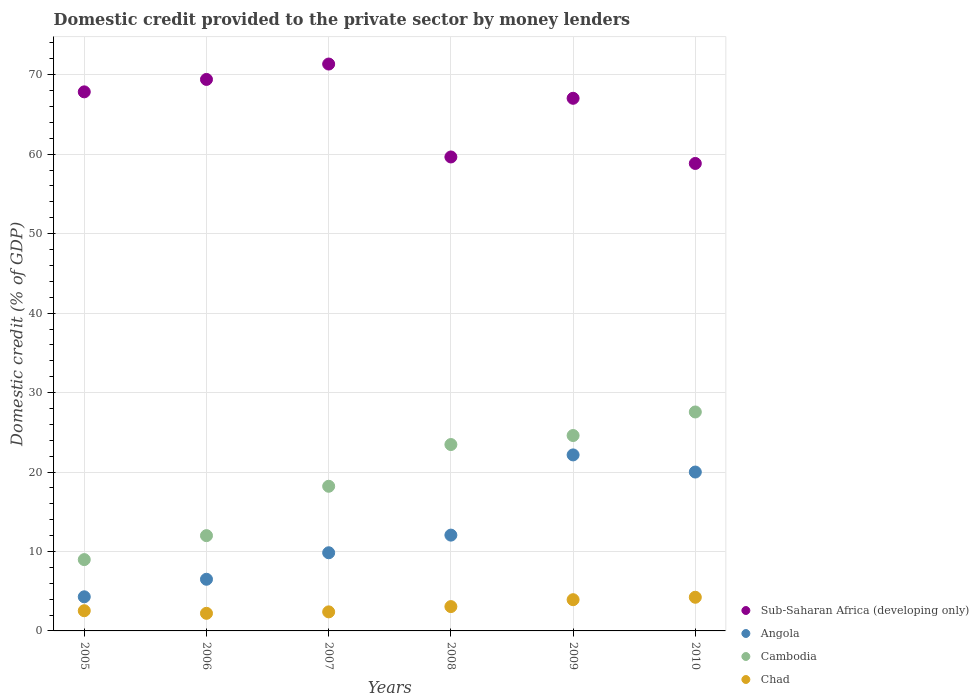How many different coloured dotlines are there?
Offer a very short reply. 4. Is the number of dotlines equal to the number of legend labels?
Offer a very short reply. Yes. What is the domestic credit provided to the private sector by money lenders in Angola in 2007?
Offer a terse response. 9.84. Across all years, what is the maximum domestic credit provided to the private sector by money lenders in Angola?
Offer a very short reply. 22.15. Across all years, what is the minimum domestic credit provided to the private sector by money lenders in Sub-Saharan Africa (developing only)?
Make the answer very short. 58.84. In which year was the domestic credit provided to the private sector by money lenders in Angola minimum?
Offer a very short reply. 2005. What is the total domestic credit provided to the private sector by money lenders in Cambodia in the graph?
Your answer should be compact. 114.79. What is the difference between the domestic credit provided to the private sector by money lenders in Angola in 2005 and that in 2009?
Make the answer very short. -17.86. What is the difference between the domestic credit provided to the private sector by money lenders in Sub-Saharan Africa (developing only) in 2006 and the domestic credit provided to the private sector by money lenders in Cambodia in 2005?
Your answer should be very brief. 60.44. What is the average domestic credit provided to the private sector by money lenders in Chad per year?
Keep it short and to the point. 3.06. In the year 2009, what is the difference between the domestic credit provided to the private sector by money lenders in Sub-Saharan Africa (developing only) and domestic credit provided to the private sector by money lenders in Cambodia?
Provide a short and direct response. 42.45. What is the ratio of the domestic credit provided to the private sector by money lenders in Sub-Saharan Africa (developing only) in 2005 to that in 2006?
Give a very brief answer. 0.98. Is the domestic credit provided to the private sector by money lenders in Sub-Saharan Africa (developing only) in 2008 less than that in 2010?
Give a very brief answer. No. What is the difference between the highest and the second highest domestic credit provided to the private sector by money lenders in Sub-Saharan Africa (developing only)?
Give a very brief answer. 1.94. What is the difference between the highest and the lowest domestic credit provided to the private sector by money lenders in Angola?
Your response must be concise. 17.86. Does the domestic credit provided to the private sector by money lenders in Angola monotonically increase over the years?
Your answer should be very brief. No. How are the legend labels stacked?
Offer a terse response. Vertical. What is the title of the graph?
Offer a very short reply. Domestic credit provided to the private sector by money lenders. Does "Dominica" appear as one of the legend labels in the graph?
Your response must be concise. No. What is the label or title of the Y-axis?
Your answer should be very brief. Domestic credit (% of GDP). What is the Domestic credit (% of GDP) in Sub-Saharan Africa (developing only) in 2005?
Ensure brevity in your answer.  67.85. What is the Domestic credit (% of GDP) in Angola in 2005?
Make the answer very short. 4.29. What is the Domestic credit (% of GDP) in Cambodia in 2005?
Make the answer very short. 8.98. What is the Domestic credit (% of GDP) of Chad in 2005?
Provide a short and direct response. 2.54. What is the Domestic credit (% of GDP) in Sub-Saharan Africa (developing only) in 2006?
Offer a very short reply. 69.41. What is the Domestic credit (% of GDP) of Angola in 2006?
Make the answer very short. 6.5. What is the Domestic credit (% of GDP) in Cambodia in 2006?
Your answer should be very brief. 11.99. What is the Domestic credit (% of GDP) in Chad in 2006?
Provide a succinct answer. 2.22. What is the Domestic credit (% of GDP) in Sub-Saharan Africa (developing only) in 2007?
Make the answer very short. 71.35. What is the Domestic credit (% of GDP) in Angola in 2007?
Offer a terse response. 9.84. What is the Domestic credit (% of GDP) of Cambodia in 2007?
Your answer should be compact. 18.21. What is the Domestic credit (% of GDP) of Chad in 2007?
Your answer should be compact. 2.4. What is the Domestic credit (% of GDP) in Sub-Saharan Africa (developing only) in 2008?
Ensure brevity in your answer.  59.65. What is the Domestic credit (% of GDP) of Angola in 2008?
Make the answer very short. 12.06. What is the Domestic credit (% of GDP) in Cambodia in 2008?
Provide a succinct answer. 23.46. What is the Domestic credit (% of GDP) of Chad in 2008?
Make the answer very short. 3.06. What is the Domestic credit (% of GDP) in Sub-Saharan Africa (developing only) in 2009?
Make the answer very short. 67.04. What is the Domestic credit (% of GDP) of Angola in 2009?
Provide a short and direct response. 22.15. What is the Domestic credit (% of GDP) of Cambodia in 2009?
Make the answer very short. 24.59. What is the Domestic credit (% of GDP) in Chad in 2009?
Make the answer very short. 3.93. What is the Domestic credit (% of GDP) in Sub-Saharan Africa (developing only) in 2010?
Your answer should be compact. 58.84. What is the Domestic credit (% of GDP) in Angola in 2010?
Offer a terse response. 20. What is the Domestic credit (% of GDP) of Cambodia in 2010?
Your answer should be very brief. 27.56. What is the Domestic credit (% of GDP) of Chad in 2010?
Make the answer very short. 4.24. Across all years, what is the maximum Domestic credit (% of GDP) of Sub-Saharan Africa (developing only)?
Give a very brief answer. 71.35. Across all years, what is the maximum Domestic credit (% of GDP) of Angola?
Ensure brevity in your answer.  22.15. Across all years, what is the maximum Domestic credit (% of GDP) of Cambodia?
Ensure brevity in your answer.  27.56. Across all years, what is the maximum Domestic credit (% of GDP) of Chad?
Make the answer very short. 4.24. Across all years, what is the minimum Domestic credit (% of GDP) of Sub-Saharan Africa (developing only)?
Keep it short and to the point. 58.84. Across all years, what is the minimum Domestic credit (% of GDP) in Angola?
Keep it short and to the point. 4.29. Across all years, what is the minimum Domestic credit (% of GDP) in Cambodia?
Your answer should be compact. 8.98. Across all years, what is the minimum Domestic credit (% of GDP) in Chad?
Keep it short and to the point. 2.22. What is the total Domestic credit (% of GDP) in Sub-Saharan Africa (developing only) in the graph?
Keep it short and to the point. 394.14. What is the total Domestic credit (% of GDP) in Angola in the graph?
Make the answer very short. 74.84. What is the total Domestic credit (% of GDP) in Cambodia in the graph?
Your answer should be compact. 114.79. What is the total Domestic credit (% of GDP) in Chad in the graph?
Provide a succinct answer. 18.38. What is the difference between the Domestic credit (% of GDP) in Sub-Saharan Africa (developing only) in 2005 and that in 2006?
Provide a short and direct response. -1.56. What is the difference between the Domestic credit (% of GDP) in Angola in 2005 and that in 2006?
Give a very brief answer. -2.21. What is the difference between the Domestic credit (% of GDP) in Cambodia in 2005 and that in 2006?
Give a very brief answer. -3.02. What is the difference between the Domestic credit (% of GDP) in Chad in 2005 and that in 2006?
Make the answer very short. 0.33. What is the difference between the Domestic credit (% of GDP) in Sub-Saharan Africa (developing only) in 2005 and that in 2007?
Your answer should be compact. -3.5. What is the difference between the Domestic credit (% of GDP) in Angola in 2005 and that in 2007?
Ensure brevity in your answer.  -5.54. What is the difference between the Domestic credit (% of GDP) of Cambodia in 2005 and that in 2007?
Keep it short and to the point. -9.23. What is the difference between the Domestic credit (% of GDP) in Chad in 2005 and that in 2007?
Offer a very short reply. 0.14. What is the difference between the Domestic credit (% of GDP) in Sub-Saharan Africa (developing only) in 2005 and that in 2008?
Make the answer very short. 8.2. What is the difference between the Domestic credit (% of GDP) in Angola in 2005 and that in 2008?
Make the answer very short. -7.76. What is the difference between the Domestic credit (% of GDP) of Cambodia in 2005 and that in 2008?
Provide a short and direct response. -14.48. What is the difference between the Domestic credit (% of GDP) in Chad in 2005 and that in 2008?
Make the answer very short. -0.52. What is the difference between the Domestic credit (% of GDP) in Sub-Saharan Africa (developing only) in 2005 and that in 2009?
Ensure brevity in your answer.  0.81. What is the difference between the Domestic credit (% of GDP) of Angola in 2005 and that in 2009?
Make the answer very short. -17.86. What is the difference between the Domestic credit (% of GDP) of Cambodia in 2005 and that in 2009?
Give a very brief answer. -15.62. What is the difference between the Domestic credit (% of GDP) of Chad in 2005 and that in 2009?
Keep it short and to the point. -1.39. What is the difference between the Domestic credit (% of GDP) in Sub-Saharan Africa (developing only) in 2005 and that in 2010?
Your answer should be compact. 9.01. What is the difference between the Domestic credit (% of GDP) of Angola in 2005 and that in 2010?
Offer a terse response. -15.7. What is the difference between the Domestic credit (% of GDP) in Cambodia in 2005 and that in 2010?
Provide a short and direct response. -18.58. What is the difference between the Domestic credit (% of GDP) in Chad in 2005 and that in 2010?
Keep it short and to the point. -1.7. What is the difference between the Domestic credit (% of GDP) in Sub-Saharan Africa (developing only) in 2006 and that in 2007?
Your response must be concise. -1.94. What is the difference between the Domestic credit (% of GDP) in Angola in 2006 and that in 2007?
Provide a short and direct response. -3.34. What is the difference between the Domestic credit (% of GDP) of Cambodia in 2006 and that in 2007?
Your answer should be compact. -6.21. What is the difference between the Domestic credit (% of GDP) of Chad in 2006 and that in 2007?
Make the answer very short. -0.18. What is the difference between the Domestic credit (% of GDP) in Sub-Saharan Africa (developing only) in 2006 and that in 2008?
Ensure brevity in your answer.  9.76. What is the difference between the Domestic credit (% of GDP) of Angola in 2006 and that in 2008?
Your answer should be very brief. -5.56. What is the difference between the Domestic credit (% of GDP) in Cambodia in 2006 and that in 2008?
Ensure brevity in your answer.  -11.47. What is the difference between the Domestic credit (% of GDP) in Chad in 2006 and that in 2008?
Give a very brief answer. -0.85. What is the difference between the Domestic credit (% of GDP) of Sub-Saharan Africa (developing only) in 2006 and that in 2009?
Provide a succinct answer. 2.37. What is the difference between the Domestic credit (% of GDP) in Angola in 2006 and that in 2009?
Your response must be concise. -15.65. What is the difference between the Domestic credit (% of GDP) in Cambodia in 2006 and that in 2009?
Offer a terse response. -12.6. What is the difference between the Domestic credit (% of GDP) in Chad in 2006 and that in 2009?
Your response must be concise. -1.72. What is the difference between the Domestic credit (% of GDP) of Sub-Saharan Africa (developing only) in 2006 and that in 2010?
Offer a very short reply. 10.58. What is the difference between the Domestic credit (% of GDP) of Angola in 2006 and that in 2010?
Make the answer very short. -13.5. What is the difference between the Domestic credit (% of GDP) in Cambodia in 2006 and that in 2010?
Provide a short and direct response. -15.57. What is the difference between the Domestic credit (% of GDP) in Chad in 2006 and that in 2010?
Make the answer very short. -2.02. What is the difference between the Domestic credit (% of GDP) of Sub-Saharan Africa (developing only) in 2007 and that in 2008?
Offer a very short reply. 11.7. What is the difference between the Domestic credit (% of GDP) of Angola in 2007 and that in 2008?
Ensure brevity in your answer.  -2.22. What is the difference between the Domestic credit (% of GDP) in Cambodia in 2007 and that in 2008?
Offer a terse response. -5.25. What is the difference between the Domestic credit (% of GDP) in Chad in 2007 and that in 2008?
Provide a succinct answer. -0.66. What is the difference between the Domestic credit (% of GDP) in Sub-Saharan Africa (developing only) in 2007 and that in 2009?
Offer a terse response. 4.31. What is the difference between the Domestic credit (% of GDP) of Angola in 2007 and that in 2009?
Your response must be concise. -12.32. What is the difference between the Domestic credit (% of GDP) in Cambodia in 2007 and that in 2009?
Your answer should be very brief. -6.39. What is the difference between the Domestic credit (% of GDP) in Chad in 2007 and that in 2009?
Provide a short and direct response. -1.53. What is the difference between the Domestic credit (% of GDP) of Sub-Saharan Africa (developing only) in 2007 and that in 2010?
Ensure brevity in your answer.  12.51. What is the difference between the Domestic credit (% of GDP) of Angola in 2007 and that in 2010?
Provide a succinct answer. -10.16. What is the difference between the Domestic credit (% of GDP) of Cambodia in 2007 and that in 2010?
Offer a terse response. -9.35. What is the difference between the Domestic credit (% of GDP) of Chad in 2007 and that in 2010?
Your response must be concise. -1.84. What is the difference between the Domestic credit (% of GDP) of Sub-Saharan Africa (developing only) in 2008 and that in 2009?
Make the answer very short. -7.39. What is the difference between the Domestic credit (% of GDP) of Angola in 2008 and that in 2009?
Ensure brevity in your answer.  -10.1. What is the difference between the Domestic credit (% of GDP) in Cambodia in 2008 and that in 2009?
Your answer should be very brief. -1.13. What is the difference between the Domestic credit (% of GDP) of Chad in 2008 and that in 2009?
Ensure brevity in your answer.  -0.87. What is the difference between the Domestic credit (% of GDP) of Sub-Saharan Africa (developing only) in 2008 and that in 2010?
Provide a short and direct response. 0.82. What is the difference between the Domestic credit (% of GDP) in Angola in 2008 and that in 2010?
Your answer should be compact. -7.94. What is the difference between the Domestic credit (% of GDP) in Cambodia in 2008 and that in 2010?
Offer a terse response. -4.1. What is the difference between the Domestic credit (% of GDP) in Chad in 2008 and that in 2010?
Offer a very short reply. -1.17. What is the difference between the Domestic credit (% of GDP) in Sub-Saharan Africa (developing only) in 2009 and that in 2010?
Your answer should be compact. 8.2. What is the difference between the Domestic credit (% of GDP) of Angola in 2009 and that in 2010?
Provide a succinct answer. 2.16. What is the difference between the Domestic credit (% of GDP) of Cambodia in 2009 and that in 2010?
Keep it short and to the point. -2.96. What is the difference between the Domestic credit (% of GDP) of Chad in 2009 and that in 2010?
Your answer should be very brief. -0.31. What is the difference between the Domestic credit (% of GDP) in Sub-Saharan Africa (developing only) in 2005 and the Domestic credit (% of GDP) in Angola in 2006?
Your answer should be compact. 61.35. What is the difference between the Domestic credit (% of GDP) of Sub-Saharan Africa (developing only) in 2005 and the Domestic credit (% of GDP) of Cambodia in 2006?
Keep it short and to the point. 55.86. What is the difference between the Domestic credit (% of GDP) of Sub-Saharan Africa (developing only) in 2005 and the Domestic credit (% of GDP) of Chad in 2006?
Keep it short and to the point. 65.63. What is the difference between the Domestic credit (% of GDP) in Angola in 2005 and the Domestic credit (% of GDP) in Cambodia in 2006?
Your answer should be very brief. -7.7. What is the difference between the Domestic credit (% of GDP) of Angola in 2005 and the Domestic credit (% of GDP) of Chad in 2006?
Your response must be concise. 2.08. What is the difference between the Domestic credit (% of GDP) of Cambodia in 2005 and the Domestic credit (% of GDP) of Chad in 2006?
Your answer should be very brief. 6.76. What is the difference between the Domestic credit (% of GDP) in Sub-Saharan Africa (developing only) in 2005 and the Domestic credit (% of GDP) in Angola in 2007?
Your response must be concise. 58.01. What is the difference between the Domestic credit (% of GDP) in Sub-Saharan Africa (developing only) in 2005 and the Domestic credit (% of GDP) in Cambodia in 2007?
Give a very brief answer. 49.64. What is the difference between the Domestic credit (% of GDP) in Sub-Saharan Africa (developing only) in 2005 and the Domestic credit (% of GDP) in Chad in 2007?
Your answer should be compact. 65.45. What is the difference between the Domestic credit (% of GDP) in Angola in 2005 and the Domestic credit (% of GDP) in Cambodia in 2007?
Your answer should be very brief. -13.91. What is the difference between the Domestic credit (% of GDP) in Angola in 2005 and the Domestic credit (% of GDP) in Chad in 2007?
Keep it short and to the point. 1.9. What is the difference between the Domestic credit (% of GDP) of Cambodia in 2005 and the Domestic credit (% of GDP) of Chad in 2007?
Provide a succinct answer. 6.58. What is the difference between the Domestic credit (% of GDP) in Sub-Saharan Africa (developing only) in 2005 and the Domestic credit (% of GDP) in Angola in 2008?
Your answer should be compact. 55.79. What is the difference between the Domestic credit (% of GDP) in Sub-Saharan Africa (developing only) in 2005 and the Domestic credit (% of GDP) in Cambodia in 2008?
Ensure brevity in your answer.  44.39. What is the difference between the Domestic credit (% of GDP) in Sub-Saharan Africa (developing only) in 2005 and the Domestic credit (% of GDP) in Chad in 2008?
Give a very brief answer. 64.79. What is the difference between the Domestic credit (% of GDP) in Angola in 2005 and the Domestic credit (% of GDP) in Cambodia in 2008?
Your answer should be compact. -19.16. What is the difference between the Domestic credit (% of GDP) in Angola in 2005 and the Domestic credit (% of GDP) in Chad in 2008?
Provide a succinct answer. 1.23. What is the difference between the Domestic credit (% of GDP) of Cambodia in 2005 and the Domestic credit (% of GDP) of Chad in 2008?
Keep it short and to the point. 5.91. What is the difference between the Domestic credit (% of GDP) of Sub-Saharan Africa (developing only) in 2005 and the Domestic credit (% of GDP) of Angola in 2009?
Your answer should be very brief. 45.7. What is the difference between the Domestic credit (% of GDP) in Sub-Saharan Africa (developing only) in 2005 and the Domestic credit (% of GDP) in Cambodia in 2009?
Your answer should be compact. 43.26. What is the difference between the Domestic credit (% of GDP) of Sub-Saharan Africa (developing only) in 2005 and the Domestic credit (% of GDP) of Chad in 2009?
Your answer should be very brief. 63.92. What is the difference between the Domestic credit (% of GDP) in Angola in 2005 and the Domestic credit (% of GDP) in Cambodia in 2009?
Give a very brief answer. -20.3. What is the difference between the Domestic credit (% of GDP) in Angola in 2005 and the Domestic credit (% of GDP) in Chad in 2009?
Keep it short and to the point. 0.36. What is the difference between the Domestic credit (% of GDP) in Cambodia in 2005 and the Domestic credit (% of GDP) in Chad in 2009?
Provide a succinct answer. 5.05. What is the difference between the Domestic credit (% of GDP) in Sub-Saharan Africa (developing only) in 2005 and the Domestic credit (% of GDP) in Angola in 2010?
Offer a very short reply. 47.85. What is the difference between the Domestic credit (% of GDP) of Sub-Saharan Africa (developing only) in 2005 and the Domestic credit (% of GDP) of Cambodia in 2010?
Your answer should be very brief. 40.29. What is the difference between the Domestic credit (% of GDP) in Sub-Saharan Africa (developing only) in 2005 and the Domestic credit (% of GDP) in Chad in 2010?
Your response must be concise. 63.61. What is the difference between the Domestic credit (% of GDP) of Angola in 2005 and the Domestic credit (% of GDP) of Cambodia in 2010?
Provide a short and direct response. -23.26. What is the difference between the Domestic credit (% of GDP) of Angola in 2005 and the Domestic credit (% of GDP) of Chad in 2010?
Offer a very short reply. 0.06. What is the difference between the Domestic credit (% of GDP) in Cambodia in 2005 and the Domestic credit (% of GDP) in Chad in 2010?
Make the answer very short. 4.74. What is the difference between the Domestic credit (% of GDP) in Sub-Saharan Africa (developing only) in 2006 and the Domestic credit (% of GDP) in Angola in 2007?
Your answer should be very brief. 59.58. What is the difference between the Domestic credit (% of GDP) of Sub-Saharan Africa (developing only) in 2006 and the Domestic credit (% of GDP) of Cambodia in 2007?
Keep it short and to the point. 51.21. What is the difference between the Domestic credit (% of GDP) of Sub-Saharan Africa (developing only) in 2006 and the Domestic credit (% of GDP) of Chad in 2007?
Provide a succinct answer. 67.02. What is the difference between the Domestic credit (% of GDP) in Angola in 2006 and the Domestic credit (% of GDP) in Cambodia in 2007?
Your answer should be compact. -11.7. What is the difference between the Domestic credit (% of GDP) of Angola in 2006 and the Domestic credit (% of GDP) of Chad in 2007?
Give a very brief answer. 4.1. What is the difference between the Domestic credit (% of GDP) in Cambodia in 2006 and the Domestic credit (% of GDP) in Chad in 2007?
Your response must be concise. 9.59. What is the difference between the Domestic credit (% of GDP) in Sub-Saharan Africa (developing only) in 2006 and the Domestic credit (% of GDP) in Angola in 2008?
Give a very brief answer. 57.36. What is the difference between the Domestic credit (% of GDP) in Sub-Saharan Africa (developing only) in 2006 and the Domestic credit (% of GDP) in Cambodia in 2008?
Your answer should be very brief. 45.95. What is the difference between the Domestic credit (% of GDP) in Sub-Saharan Africa (developing only) in 2006 and the Domestic credit (% of GDP) in Chad in 2008?
Your response must be concise. 66.35. What is the difference between the Domestic credit (% of GDP) of Angola in 2006 and the Domestic credit (% of GDP) of Cambodia in 2008?
Keep it short and to the point. -16.96. What is the difference between the Domestic credit (% of GDP) of Angola in 2006 and the Domestic credit (% of GDP) of Chad in 2008?
Your answer should be compact. 3.44. What is the difference between the Domestic credit (% of GDP) in Cambodia in 2006 and the Domestic credit (% of GDP) in Chad in 2008?
Offer a very short reply. 8.93. What is the difference between the Domestic credit (% of GDP) of Sub-Saharan Africa (developing only) in 2006 and the Domestic credit (% of GDP) of Angola in 2009?
Make the answer very short. 47.26. What is the difference between the Domestic credit (% of GDP) in Sub-Saharan Africa (developing only) in 2006 and the Domestic credit (% of GDP) in Cambodia in 2009?
Make the answer very short. 44.82. What is the difference between the Domestic credit (% of GDP) in Sub-Saharan Africa (developing only) in 2006 and the Domestic credit (% of GDP) in Chad in 2009?
Offer a very short reply. 65.48. What is the difference between the Domestic credit (% of GDP) of Angola in 2006 and the Domestic credit (% of GDP) of Cambodia in 2009?
Offer a very short reply. -18.09. What is the difference between the Domestic credit (% of GDP) in Angola in 2006 and the Domestic credit (% of GDP) in Chad in 2009?
Give a very brief answer. 2.57. What is the difference between the Domestic credit (% of GDP) in Cambodia in 2006 and the Domestic credit (% of GDP) in Chad in 2009?
Your answer should be very brief. 8.06. What is the difference between the Domestic credit (% of GDP) in Sub-Saharan Africa (developing only) in 2006 and the Domestic credit (% of GDP) in Angola in 2010?
Provide a succinct answer. 49.42. What is the difference between the Domestic credit (% of GDP) in Sub-Saharan Africa (developing only) in 2006 and the Domestic credit (% of GDP) in Cambodia in 2010?
Your answer should be compact. 41.86. What is the difference between the Domestic credit (% of GDP) of Sub-Saharan Africa (developing only) in 2006 and the Domestic credit (% of GDP) of Chad in 2010?
Your answer should be very brief. 65.18. What is the difference between the Domestic credit (% of GDP) in Angola in 2006 and the Domestic credit (% of GDP) in Cambodia in 2010?
Offer a very short reply. -21.06. What is the difference between the Domestic credit (% of GDP) of Angola in 2006 and the Domestic credit (% of GDP) of Chad in 2010?
Ensure brevity in your answer.  2.27. What is the difference between the Domestic credit (% of GDP) in Cambodia in 2006 and the Domestic credit (% of GDP) in Chad in 2010?
Your answer should be very brief. 7.76. What is the difference between the Domestic credit (% of GDP) of Sub-Saharan Africa (developing only) in 2007 and the Domestic credit (% of GDP) of Angola in 2008?
Provide a succinct answer. 59.29. What is the difference between the Domestic credit (% of GDP) of Sub-Saharan Africa (developing only) in 2007 and the Domestic credit (% of GDP) of Cambodia in 2008?
Your response must be concise. 47.89. What is the difference between the Domestic credit (% of GDP) in Sub-Saharan Africa (developing only) in 2007 and the Domestic credit (% of GDP) in Chad in 2008?
Ensure brevity in your answer.  68.29. What is the difference between the Domestic credit (% of GDP) of Angola in 2007 and the Domestic credit (% of GDP) of Cambodia in 2008?
Your answer should be compact. -13.62. What is the difference between the Domestic credit (% of GDP) in Angola in 2007 and the Domestic credit (% of GDP) in Chad in 2008?
Offer a terse response. 6.78. What is the difference between the Domestic credit (% of GDP) of Cambodia in 2007 and the Domestic credit (% of GDP) of Chad in 2008?
Provide a short and direct response. 15.14. What is the difference between the Domestic credit (% of GDP) of Sub-Saharan Africa (developing only) in 2007 and the Domestic credit (% of GDP) of Angola in 2009?
Provide a short and direct response. 49.2. What is the difference between the Domestic credit (% of GDP) of Sub-Saharan Africa (developing only) in 2007 and the Domestic credit (% of GDP) of Cambodia in 2009?
Ensure brevity in your answer.  46.76. What is the difference between the Domestic credit (% of GDP) in Sub-Saharan Africa (developing only) in 2007 and the Domestic credit (% of GDP) in Chad in 2009?
Make the answer very short. 67.42. What is the difference between the Domestic credit (% of GDP) in Angola in 2007 and the Domestic credit (% of GDP) in Cambodia in 2009?
Make the answer very short. -14.76. What is the difference between the Domestic credit (% of GDP) in Angola in 2007 and the Domestic credit (% of GDP) in Chad in 2009?
Keep it short and to the point. 5.91. What is the difference between the Domestic credit (% of GDP) in Cambodia in 2007 and the Domestic credit (% of GDP) in Chad in 2009?
Offer a very short reply. 14.28. What is the difference between the Domestic credit (% of GDP) of Sub-Saharan Africa (developing only) in 2007 and the Domestic credit (% of GDP) of Angola in 2010?
Provide a short and direct response. 51.35. What is the difference between the Domestic credit (% of GDP) in Sub-Saharan Africa (developing only) in 2007 and the Domestic credit (% of GDP) in Cambodia in 2010?
Provide a succinct answer. 43.79. What is the difference between the Domestic credit (% of GDP) of Sub-Saharan Africa (developing only) in 2007 and the Domestic credit (% of GDP) of Chad in 2010?
Your response must be concise. 67.11. What is the difference between the Domestic credit (% of GDP) of Angola in 2007 and the Domestic credit (% of GDP) of Cambodia in 2010?
Provide a succinct answer. -17.72. What is the difference between the Domestic credit (% of GDP) of Angola in 2007 and the Domestic credit (% of GDP) of Chad in 2010?
Your response must be concise. 5.6. What is the difference between the Domestic credit (% of GDP) in Cambodia in 2007 and the Domestic credit (% of GDP) in Chad in 2010?
Offer a very short reply. 13.97. What is the difference between the Domestic credit (% of GDP) of Sub-Saharan Africa (developing only) in 2008 and the Domestic credit (% of GDP) of Angola in 2009?
Provide a short and direct response. 37.5. What is the difference between the Domestic credit (% of GDP) of Sub-Saharan Africa (developing only) in 2008 and the Domestic credit (% of GDP) of Cambodia in 2009?
Your response must be concise. 35.06. What is the difference between the Domestic credit (% of GDP) in Sub-Saharan Africa (developing only) in 2008 and the Domestic credit (% of GDP) in Chad in 2009?
Provide a short and direct response. 55.72. What is the difference between the Domestic credit (% of GDP) in Angola in 2008 and the Domestic credit (% of GDP) in Cambodia in 2009?
Keep it short and to the point. -12.54. What is the difference between the Domestic credit (% of GDP) of Angola in 2008 and the Domestic credit (% of GDP) of Chad in 2009?
Keep it short and to the point. 8.13. What is the difference between the Domestic credit (% of GDP) of Cambodia in 2008 and the Domestic credit (% of GDP) of Chad in 2009?
Your answer should be very brief. 19.53. What is the difference between the Domestic credit (% of GDP) in Sub-Saharan Africa (developing only) in 2008 and the Domestic credit (% of GDP) in Angola in 2010?
Provide a short and direct response. 39.66. What is the difference between the Domestic credit (% of GDP) in Sub-Saharan Africa (developing only) in 2008 and the Domestic credit (% of GDP) in Cambodia in 2010?
Offer a terse response. 32.1. What is the difference between the Domestic credit (% of GDP) in Sub-Saharan Africa (developing only) in 2008 and the Domestic credit (% of GDP) in Chad in 2010?
Offer a very short reply. 55.42. What is the difference between the Domestic credit (% of GDP) in Angola in 2008 and the Domestic credit (% of GDP) in Cambodia in 2010?
Make the answer very short. -15.5. What is the difference between the Domestic credit (% of GDP) of Angola in 2008 and the Domestic credit (% of GDP) of Chad in 2010?
Your answer should be compact. 7.82. What is the difference between the Domestic credit (% of GDP) of Cambodia in 2008 and the Domestic credit (% of GDP) of Chad in 2010?
Your response must be concise. 19.22. What is the difference between the Domestic credit (% of GDP) of Sub-Saharan Africa (developing only) in 2009 and the Domestic credit (% of GDP) of Angola in 2010?
Your answer should be compact. 47.04. What is the difference between the Domestic credit (% of GDP) of Sub-Saharan Africa (developing only) in 2009 and the Domestic credit (% of GDP) of Cambodia in 2010?
Provide a short and direct response. 39.48. What is the difference between the Domestic credit (% of GDP) in Sub-Saharan Africa (developing only) in 2009 and the Domestic credit (% of GDP) in Chad in 2010?
Give a very brief answer. 62.8. What is the difference between the Domestic credit (% of GDP) of Angola in 2009 and the Domestic credit (% of GDP) of Cambodia in 2010?
Offer a very short reply. -5.4. What is the difference between the Domestic credit (% of GDP) of Angola in 2009 and the Domestic credit (% of GDP) of Chad in 2010?
Your answer should be compact. 17.92. What is the difference between the Domestic credit (% of GDP) in Cambodia in 2009 and the Domestic credit (% of GDP) in Chad in 2010?
Ensure brevity in your answer.  20.36. What is the average Domestic credit (% of GDP) in Sub-Saharan Africa (developing only) per year?
Provide a succinct answer. 65.69. What is the average Domestic credit (% of GDP) in Angola per year?
Offer a terse response. 12.47. What is the average Domestic credit (% of GDP) of Cambodia per year?
Provide a short and direct response. 19.13. What is the average Domestic credit (% of GDP) of Chad per year?
Offer a very short reply. 3.06. In the year 2005, what is the difference between the Domestic credit (% of GDP) in Sub-Saharan Africa (developing only) and Domestic credit (% of GDP) in Angola?
Make the answer very short. 63.55. In the year 2005, what is the difference between the Domestic credit (% of GDP) of Sub-Saharan Africa (developing only) and Domestic credit (% of GDP) of Cambodia?
Offer a terse response. 58.87. In the year 2005, what is the difference between the Domestic credit (% of GDP) in Sub-Saharan Africa (developing only) and Domestic credit (% of GDP) in Chad?
Offer a very short reply. 65.31. In the year 2005, what is the difference between the Domestic credit (% of GDP) of Angola and Domestic credit (% of GDP) of Cambodia?
Ensure brevity in your answer.  -4.68. In the year 2005, what is the difference between the Domestic credit (% of GDP) of Angola and Domestic credit (% of GDP) of Chad?
Keep it short and to the point. 1.75. In the year 2005, what is the difference between the Domestic credit (% of GDP) of Cambodia and Domestic credit (% of GDP) of Chad?
Your response must be concise. 6.43. In the year 2006, what is the difference between the Domestic credit (% of GDP) of Sub-Saharan Africa (developing only) and Domestic credit (% of GDP) of Angola?
Your answer should be very brief. 62.91. In the year 2006, what is the difference between the Domestic credit (% of GDP) in Sub-Saharan Africa (developing only) and Domestic credit (% of GDP) in Cambodia?
Your answer should be compact. 57.42. In the year 2006, what is the difference between the Domestic credit (% of GDP) of Sub-Saharan Africa (developing only) and Domestic credit (% of GDP) of Chad?
Your answer should be compact. 67.2. In the year 2006, what is the difference between the Domestic credit (% of GDP) of Angola and Domestic credit (% of GDP) of Cambodia?
Make the answer very short. -5.49. In the year 2006, what is the difference between the Domestic credit (% of GDP) of Angola and Domestic credit (% of GDP) of Chad?
Offer a terse response. 4.29. In the year 2006, what is the difference between the Domestic credit (% of GDP) of Cambodia and Domestic credit (% of GDP) of Chad?
Your response must be concise. 9.78. In the year 2007, what is the difference between the Domestic credit (% of GDP) of Sub-Saharan Africa (developing only) and Domestic credit (% of GDP) of Angola?
Ensure brevity in your answer.  61.51. In the year 2007, what is the difference between the Domestic credit (% of GDP) of Sub-Saharan Africa (developing only) and Domestic credit (% of GDP) of Cambodia?
Your answer should be very brief. 53.14. In the year 2007, what is the difference between the Domestic credit (% of GDP) in Sub-Saharan Africa (developing only) and Domestic credit (% of GDP) in Chad?
Ensure brevity in your answer.  68.95. In the year 2007, what is the difference between the Domestic credit (% of GDP) of Angola and Domestic credit (% of GDP) of Cambodia?
Your answer should be compact. -8.37. In the year 2007, what is the difference between the Domestic credit (% of GDP) of Angola and Domestic credit (% of GDP) of Chad?
Give a very brief answer. 7.44. In the year 2007, what is the difference between the Domestic credit (% of GDP) of Cambodia and Domestic credit (% of GDP) of Chad?
Offer a very short reply. 15.81. In the year 2008, what is the difference between the Domestic credit (% of GDP) in Sub-Saharan Africa (developing only) and Domestic credit (% of GDP) in Angola?
Your answer should be compact. 47.6. In the year 2008, what is the difference between the Domestic credit (% of GDP) in Sub-Saharan Africa (developing only) and Domestic credit (% of GDP) in Cambodia?
Make the answer very short. 36.19. In the year 2008, what is the difference between the Domestic credit (% of GDP) of Sub-Saharan Africa (developing only) and Domestic credit (% of GDP) of Chad?
Ensure brevity in your answer.  56.59. In the year 2008, what is the difference between the Domestic credit (% of GDP) in Angola and Domestic credit (% of GDP) in Cambodia?
Offer a very short reply. -11.4. In the year 2008, what is the difference between the Domestic credit (% of GDP) in Angola and Domestic credit (% of GDP) in Chad?
Offer a terse response. 9. In the year 2008, what is the difference between the Domestic credit (% of GDP) of Cambodia and Domestic credit (% of GDP) of Chad?
Offer a very short reply. 20.4. In the year 2009, what is the difference between the Domestic credit (% of GDP) of Sub-Saharan Africa (developing only) and Domestic credit (% of GDP) of Angola?
Ensure brevity in your answer.  44.89. In the year 2009, what is the difference between the Domestic credit (% of GDP) in Sub-Saharan Africa (developing only) and Domestic credit (% of GDP) in Cambodia?
Give a very brief answer. 42.45. In the year 2009, what is the difference between the Domestic credit (% of GDP) in Sub-Saharan Africa (developing only) and Domestic credit (% of GDP) in Chad?
Make the answer very short. 63.11. In the year 2009, what is the difference between the Domestic credit (% of GDP) in Angola and Domestic credit (% of GDP) in Cambodia?
Your response must be concise. -2.44. In the year 2009, what is the difference between the Domestic credit (% of GDP) of Angola and Domestic credit (% of GDP) of Chad?
Your answer should be compact. 18.22. In the year 2009, what is the difference between the Domestic credit (% of GDP) in Cambodia and Domestic credit (% of GDP) in Chad?
Provide a short and direct response. 20.66. In the year 2010, what is the difference between the Domestic credit (% of GDP) of Sub-Saharan Africa (developing only) and Domestic credit (% of GDP) of Angola?
Make the answer very short. 38.84. In the year 2010, what is the difference between the Domestic credit (% of GDP) of Sub-Saharan Africa (developing only) and Domestic credit (% of GDP) of Cambodia?
Offer a terse response. 31.28. In the year 2010, what is the difference between the Domestic credit (% of GDP) in Sub-Saharan Africa (developing only) and Domestic credit (% of GDP) in Chad?
Provide a short and direct response. 54.6. In the year 2010, what is the difference between the Domestic credit (% of GDP) of Angola and Domestic credit (% of GDP) of Cambodia?
Keep it short and to the point. -7.56. In the year 2010, what is the difference between the Domestic credit (% of GDP) of Angola and Domestic credit (% of GDP) of Chad?
Your response must be concise. 15.76. In the year 2010, what is the difference between the Domestic credit (% of GDP) of Cambodia and Domestic credit (% of GDP) of Chad?
Your answer should be compact. 23.32. What is the ratio of the Domestic credit (% of GDP) in Sub-Saharan Africa (developing only) in 2005 to that in 2006?
Give a very brief answer. 0.98. What is the ratio of the Domestic credit (% of GDP) in Angola in 2005 to that in 2006?
Your answer should be very brief. 0.66. What is the ratio of the Domestic credit (% of GDP) of Cambodia in 2005 to that in 2006?
Offer a very short reply. 0.75. What is the ratio of the Domestic credit (% of GDP) in Chad in 2005 to that in 2006?
Offer a very short reply. 1.15. What is the ratio of the Domestic credit (% of GDP) of Sub-Saharan Africa (developing only) in 2005 to that in 2007?
Your response must be concise. 0.95. What is the ratio of the Domestic credit (% of GDP) in Angola in 2005 to that in 2007?
Offer a very short reply. 0.44. What is the ratio of the Domestic credit (% of GDP) in Cambodia in 2005 to that in 2007?
Your answer should be very brief. 0.49. What is the ratio of the Domestic credit (% of GDP) in Chad in 2005 to that in 2007?
Your answer should be very brief. 1.06. What is the ratio of the Domestic credit (% of GDP) in Sub-Saharan Africa (developing only) in 2005 to that in 2008?
Provide a succinct answer. 1.14. What is the ratio of the Domestic credit (% of GDP) of Angola in 2005 to that in 2008?
Make the answer very short. 0.36. What is the ratio of the Domestic credit (% of GDP) in Cambodia in 2005 to that in 2008?
Provide a succinct answer. 0.38. What is the ratio of the Domestic credit (% of GDP) of Chad in 2005 to that in 2008?
Keep it short and to the point. 0.83. What is the ratio of the Domestic credit (% of GDP) in Sub-Saharan Africa (developing only) in 2005 to that in 2009?
Offer a very short reply. 1.01. What is the ratio of the Domestic credit (% of GDP) of Angola in 2005 to that in 2009?
Keep it short and to the point. 0.19. What is the ratio of the Domestic credit (% of GDP) in Cambodia in 2005 to that in 2009?
Ensure brevity in your answer.  0.36. What is the ratio of the Domestic credit (% of GDP) in Chad in 2005 to that in 2009?
Make the answer very short. 0.65. What is the ratio of the Domestic credit (% of GDP) in Sub-Saharan Africa (developing only) in 2005 to that in 2010?
Give a very brief answer. 1.15. What is the ratio of the Domestic credit (% of GDP) in Angola in 2005 to that in 2010?
Ensure brevity in your answer.  0.21. What is the ratio of the Domestic credit (% of GDP) in Cambodia in 2005 to that in 2010?
Ensure brevity in your answer.  0.33. What is the ratio of the Domestic credit (% of GDP) of Chad in 2005 to that in 2010?
Offer a terse response. 0.6. What is the ratio of the Domestic credit (% of GDP) in Sub-Saharan Africa (developing only) in 2006 to that in 2007?
Make the answer very short. 0.97. What is the ratio of the Domestic credit (% of GDP) of Angola in 2006 to that in 2007?
Give a very brief answer. 0.66. What is the ratio of the Domestic credit (% of GDP) in Cambodia in 2006 to that in 2007?
Your answer should be compact. 0.66. What is the ratio of the Domestic credit (% of GDP) in Chad in 2006 to that in 2007?
Your response must be concise. 0.92. What is the ratio of the Domestic credit (% of GDP) in Sub-Saharan Africa (developing only) in 2006 to that in 2008?
Offer a terse response. 1.16. What is the ratio of the Domestic credit (% of GDP) of Angola in 2006 to that in 2008?
Provide a succinct answer. 0.54. What is the ratio of the Domestic credit (% of GDP) of Cambodia in 2006 to that in 2008?
Offer a very short reply. 0.51. What is the ratio of the Domestic credit (% of GDP) in Chad in 2006 to that in 2008?
Provide a short and direct response. 0.72. What is the ratio of the Domestic credit (% of GDP) of Sub-Saharan Africa (developing only) in 2006 to that in 2009?
Ensure brevity in your answer.  1.04. What is the ratio of the Domestic credit (% of GDP) of Angola in 2006 to that in 2009?
Provide a succinct answer. 0.29. What is the ratio of the Domestic credit (% of GDP) of Cambodia in 2006 to that in 2009?
Your answer should be compact. 0.49. What is the ratio of the Domestic credit (% of GDP) of Chad in 2006 to that in 2009?
Make the answer very short. 0.56. What is the ratio of the Domestic credit (% of GDP) of Sub-Saharan Africa (developing only) in 2006 to that in 2010?
Provide a short and direct response. 1.18. What is the ratio of the Domestic credit (% of GDP) of Angola in 2006 to that in 2010?
Give a very brief answer. 0.33. What is the ratio of the Domestic credit (% of GDP) of Cambodia in 2006 to that in 2010?
Keep it short and to the point. 0.44. What is the ratio of the Domestic credit (% of GDP) in Chad in 2006 to that in 2010?
Offer a very short reply. 0.52. What is the ratio of the Domestic credit (% of GDP) of Sub-Saharan Africa (developing only) in 2007 to that in 2008?
Provide a short and direct response. 1.2. What is the ratio of the Domestic credit (% of GDP) in Angola in 2007 to that in 2008?
Provide a succinct answer. 0.82. What is the ratio of the Domestic credit (% of GDP) in Cambodia in 2007 to that in 2008?
Your response must be concise. 0.78. What is the ratio of the Domestic credit (% of GDP) of Chad in 2007 to that in 2008?
Your answer should be very brief. 0.78. What is the ratio of the Domestic credit (% of GDP) in Sub-Saharan Africa (developing only) in 2007 to that in 2009?
Your response must be concise. 1.06. What is the ratio of the Domestic credit (% of GDP) in Angola in 2007 to that in 2009?
Your response must be concise. 0.44. What is the ratio of the Domestic credit (% of GDP) of Cambodia in 2007 to that in 2009?
Provide a succinct answer. 0.74. What is the ratio of the Domestic credit (% of GDP) of Chad in 2007 to that in 2009?
Your answer should be very brief. 0.61. What is the ratio of the Domestic credit (% of GDP) of Sub-Saharan Africa (developing only) in 2007 to that in 2010?
Ensure brevity in your answer.  1.21. What is the ratio of the Domestic credit (% of GDP) in Angola in 2007 to that in 2010?
Make the answer very short. 0.49. What is the ratio of the Domestic credit (% of GDP) of Cambodia in 2007 to that in 2010?
Make the answer very short. 0.66. What is the ratio of the Domestic credit (% of GDP) in Chad in 2007 to that in 2010?
Your answer should be compact. 0.57. What is the ratio of the Domestic credit (% of GDP) of Sub-Saharan Africa (developing only) in 2008 to that in 2009?
Your answer should be very brief. 0.89. What is the ratio of the Domestic credit (% of GDP) of Angola in 2008 to that in 2009?
Your answer should be compact. 0.54. What is the ratio of the Domestic credit (% of GDP) of Cambodia in 2008 to that in 2009?
Give a very brief answer. 0.95. What is the ratio of the Domestic credit (% of GDP) of Chad in 2008 to that in 2009?
Offer a very short reply. 0.78. What is the ratio of the Domestic credit (% of GDP) in Sub-Saharan Africa (developing only) in 2008 to that in 2010?
Provide a short and direct response. 1.01. What is the ratio of the Domestic credit (% of GDP) in Angola in 2008 to that in 2010?
Provide a short and direct response. 0.6. What is the ratio of the Domestic credit (% of GDP) in Cambodia in 2008 to that in 2010?
Offer a very short reply. 0.85. What is the ratio of the Domestic credit (% of GDP) of Chad in 2008 to that in 2010?
Provide a succinct answer. 0.72. What is the ratio of the Domestic credit (% of GDP) in Sub-Saharan Africa (developing only) in 2009 to that in 2010?
Provide a succinct answer. 1.14. What is the ratio of the Domestic credit (% of GDP) in Angola in 2009 to that in 2010?
Offer a very short reply. 1.11. What is the ratio of the Domestic credit (% of GDP) of Cambodia in 2009 to that in 2010?
Provide a short and direct response. 0.89. What is the ratio of the Domestic credit (% of GDP) in Chad in 2009 to that in 2010?
Your response must be concise. 0.93. What is the difference between the highest and the second highest Domestic credit (% of GDP) in Sub-Saharan Africa (developing only)?
Offer a very short reply. 1.94. What is the difference between the highest and the second highest Domestic credit (% of GDP) in Angola?
Offer a very short reply. 2.16. What is the difference between the highest and the second highest Domestic credit (% of GDP) of Cambodia?
Ensure brevity in your answer.  2.96. What is the difference between the highest and the second highest Domestic credit (% of GDP) of Chad?
Your answer should be compact. 0.31. What is the difference between the highest and the lowest Domestic credit (% of GDP) of Sub-Saharan Africa (developing only)?
Your response must be concise. 12.51. What is the difference between the highest and the lowest Domestic credit (% of GDP) of Angola?
Your response must be concise. 17.86. What is the difference between the highest and the lowest Domestic credit (% of GDP) of Cambodia?
Offer a very short reply. 18.58. What is the difference between the highest and the lowest Domestic credit (% of GDP) of Chad?
Offer a very short reply. 2.02. 